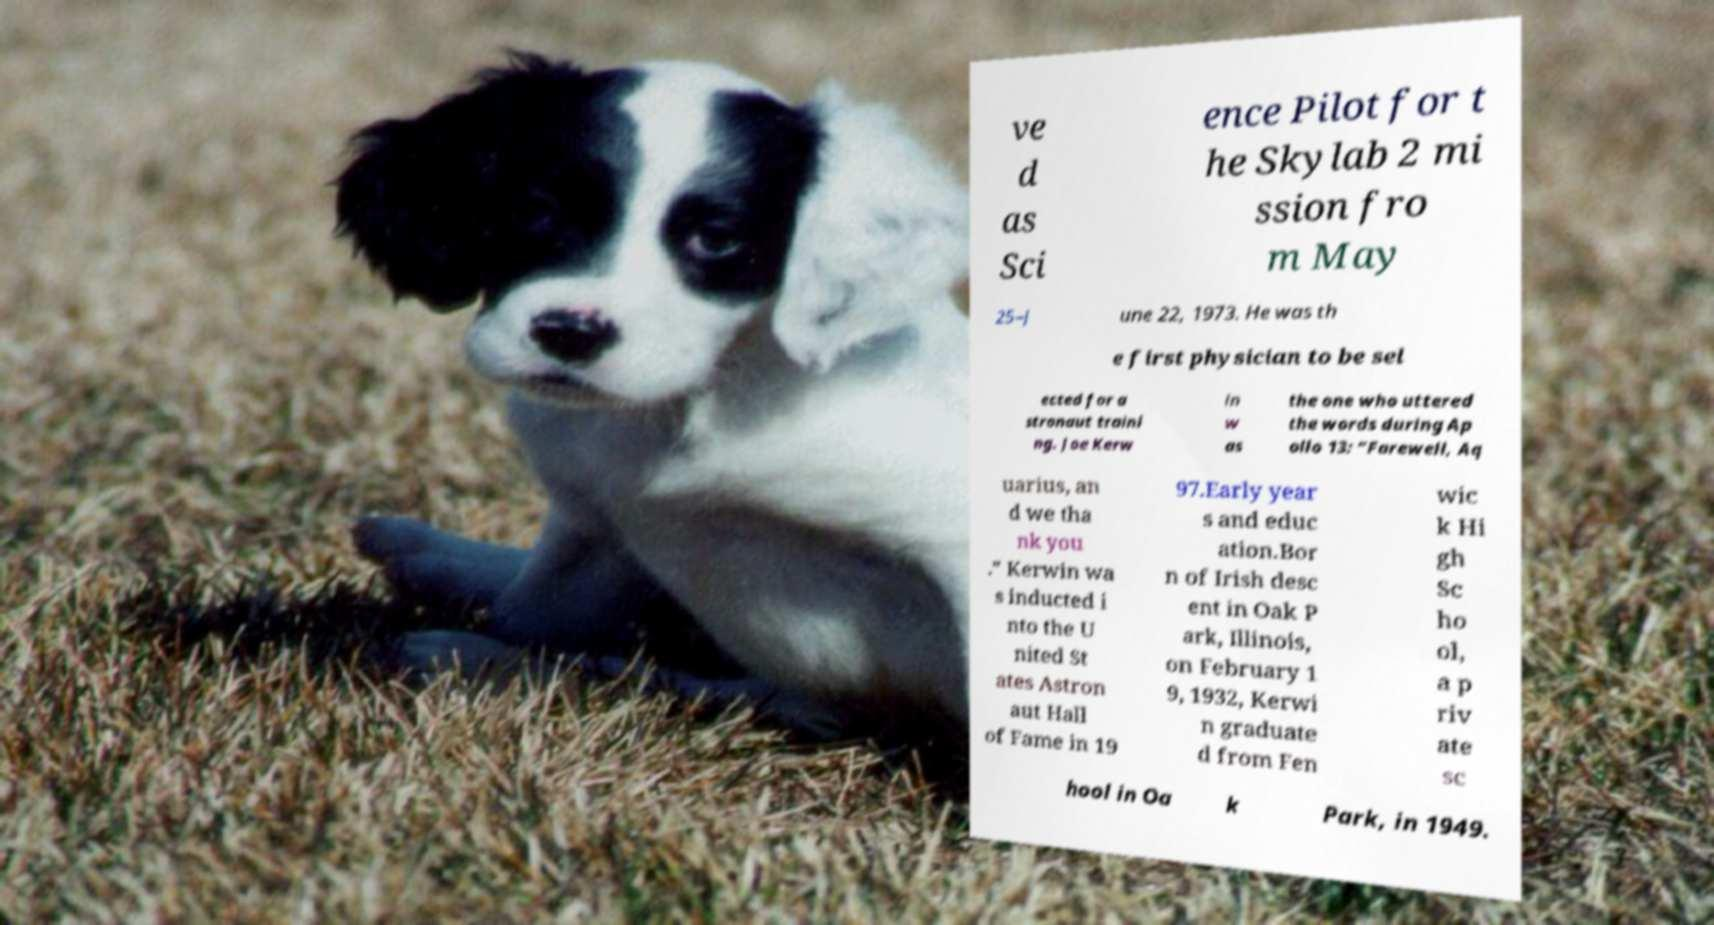Could you extract and type out the text from this image? ve d as Sci ence Pilot for t he Skylab 2 mi ssion fro m May 25–J une 22, 1973. He was th e first physician to be sel ected for a stronaut traini ng. Joe Kerw in w as the one who uttered the words during Ap ollo 13: “Farewell, Aq uarius, an d we tha nk you .” Kerwin wa s inducted i nto the U nited St ates Astron aut Hall of Fame in 19 97.Early year s and educ ation.Bor n of Irish desc ent in Oak P ark, Illinois, on February 1 9, 1932, Kerwi n graduate d from Fen wic k Hi gh Sc ho ol, a p riv ate sc hool in Oa k Park, in 1949. 